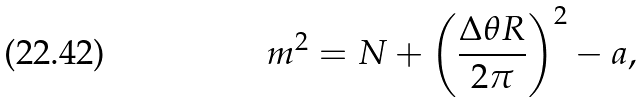<formula> <loc_0><loc_0><loc_500><loc_500>m ^ { 2 } = N + \left ( \frac { \Delta { \theta } R } { 2 \pi } \right ) ^ { 2 } - a ,</formula> 